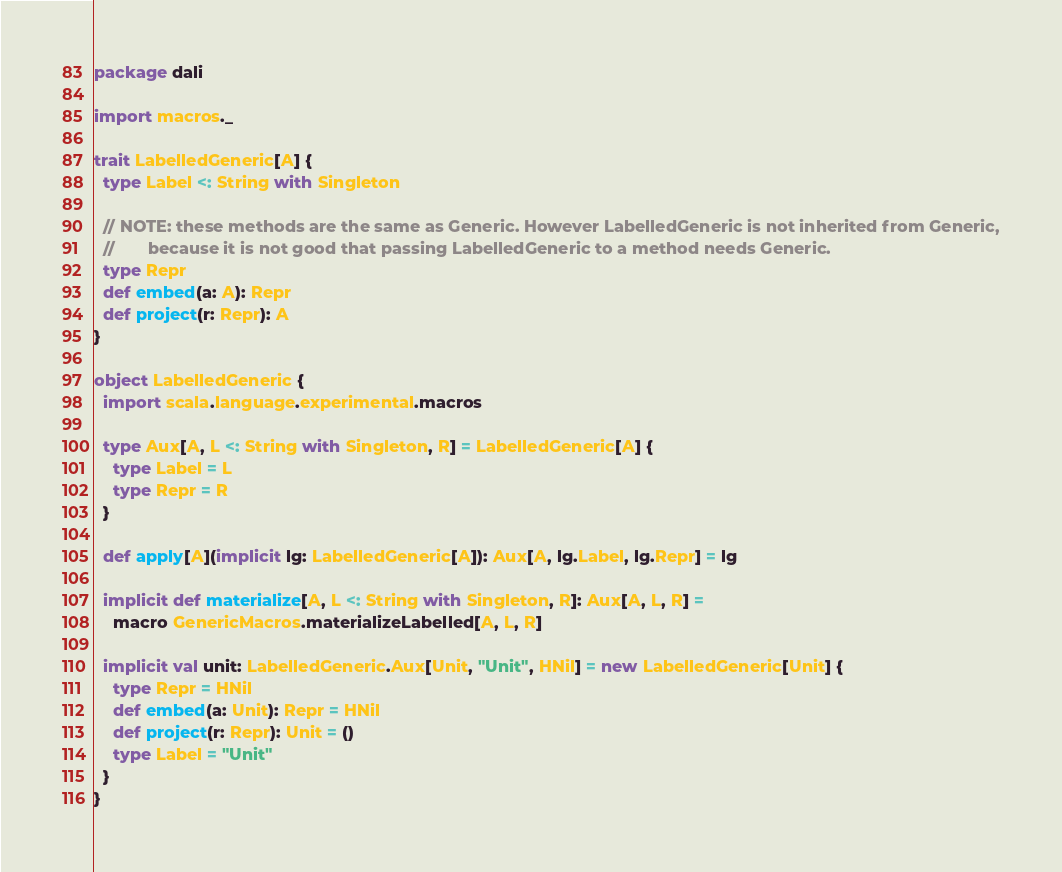<code> <loc_0><loc_0><loc_500><loc_500><_Scala_>package dali

import macros._

trait LabelledGeneric[A] {
  type Label <: String with Singleton

  // NOTE: these methods are the same as Generic. However LabelledGeneric is not inherited from Generic,
  //       because it is not good that passing LabelledGeneric to a method needs Generic.
  type Repr
  def embed(a: A): Repr
  def project(r: Repr): A
}

object LabelledGeneric {
  import scala.language.experimental.macros

  type Aux[A, L <: String with Singleton, R] = LabelledGeneric[A] {
    type Label = L
    type Repr = R
  }

  def apply[A](implicit lg: LabelledGeneric[A]): Aux[A, lg.Label, lg.Repr] = lg

  implicit def materialize[A, L <: String with Singleton, R]: Aux[A, L, R] =
    macro GenericMacros.materializeLabelled[A, L, R]

  implicit val unit: LabelledGeneric.Aux[Unit, "Unit", HNil] = new LabelledGeneric[Unit] {
    type Repr = HNil
    def embed(a: Unit): Repr = HNil
    def project(r: Repr): Unit = ()
    type Label = "Unit"
  }
}
</code> 